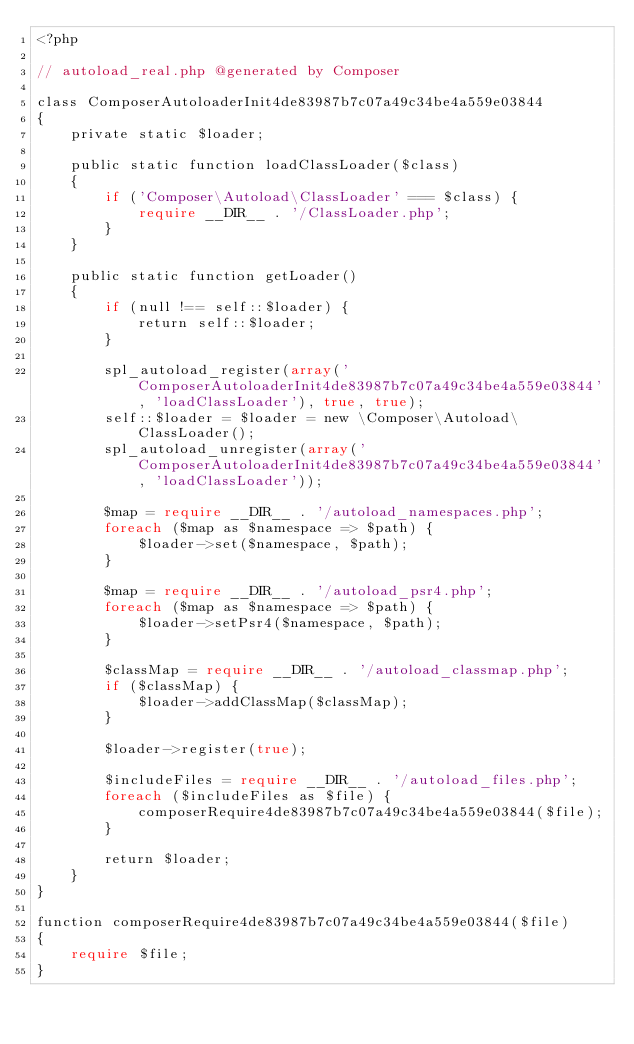Convert code to text. <code><loc_0><loc_0><loc_500><loc_500><_PHP_><?php

// autoload_real.php @generated by Composer

class ComposerAutoloaderInit4de83987b7c07a49c34be4a559e03844
{
    private static $loader;

    public static function loadClassLoader($class)
    {
        if ('Composer\Autoload\ClassLoader' === $class) {
            require __DIR__ . '/ClassLoader.php';
        }
    }

    public static function getLoader()
    {
        if (null !== self::$loader) {
            return self::$loader;
        }

        spl_autoload_register(array('ComposerAutoloaderInit4de83987b7c07a49c34be4a559e03844', 'loadClassLoader'), true, true);
        self::$loader = $loader = new \Composer\Autoload\ClassLoader();
        spl_autoload_unregister(array('ComposerAutoloaderInit4de83987b7c07a49c34be4a559e03844', 'loadClassLoader'));

        $map = require __DIR__ . '/autoload_namespaces.php';
        foreach ($map as $namespace => $path) {
            $loader->set($namespace, $path);
        }

        $map = require __DIR__ . '/autoload_psr4.php';
        foreach ($map as $namespace => $path) {
            $loader->setPsr4($namespace, $path);
        }

        $classMap = require __DIR__ . '/autoload_classmap.php';
        if ($classMap) {
            $loader->addClassMap($classMap);
        }

        $loader->register(true);

        $includeFiles = require __DIR__ . '/autoload_files.php';
        foreach ($includeFiles as $file) {
            composerRequire4de83987b7c07a49c34be4a559e03844($file);
        }

        return $loader;
    }
}

function composerRequire4de83987b7c07a49c34be4a559e03844($file)
{
    require $file;
}
</code> 